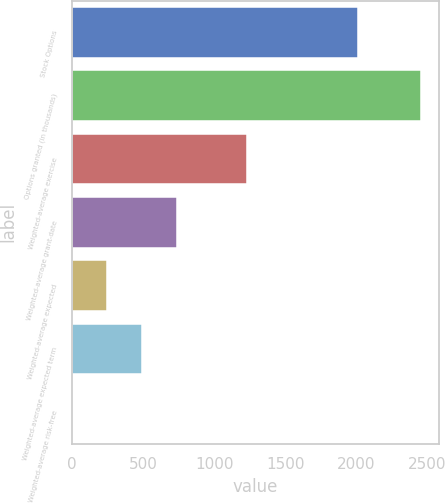<chart> <loc_0><loc_0><loc_500><loc_500><bar_chart><fcel>Stock Options<fcel>Options granted (in thousands)<fcel>Weighted-average exercise<fcel>Weighted-average grant-date<fcel>Weighted-average expected<fcel>Weighted-average expected term<fcel>Weighted-average risk-free<nl><fcel>2012<fcel>2456<fcel>1228.55<fcel>737.57<fcel>246.59<fcel>492.08<fcel>1.1<nl></chart> 